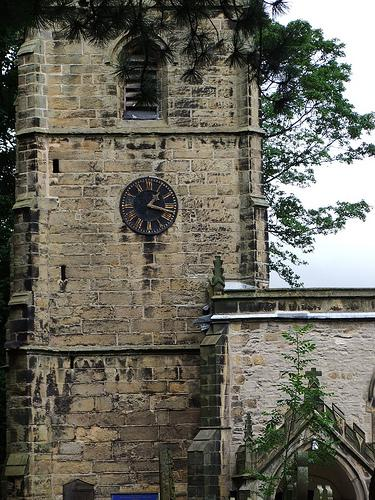Question: where was this photo taken?
Choices:
A. At the museum.
B. At the zoo.
C. At a vintage church.
D. In the park.
Answer with the letter. Answer: C Question: what is in the photo?
Choices:
A. A building.
B. A cloud.
C. A tree.
D. A mountain.
Answer with the letter. Answer: A Question: what is on the building?
Choices:
A. Graffiti.
B. Dirt.
C. Bird poop.
D. A clock.
Answer with the letter. Answer: D Question: how is the photo?
Choices:
A. Bright.
B. Colorful.
C. Clear.
D. Professional.
Answer with the letter. Answer: C 